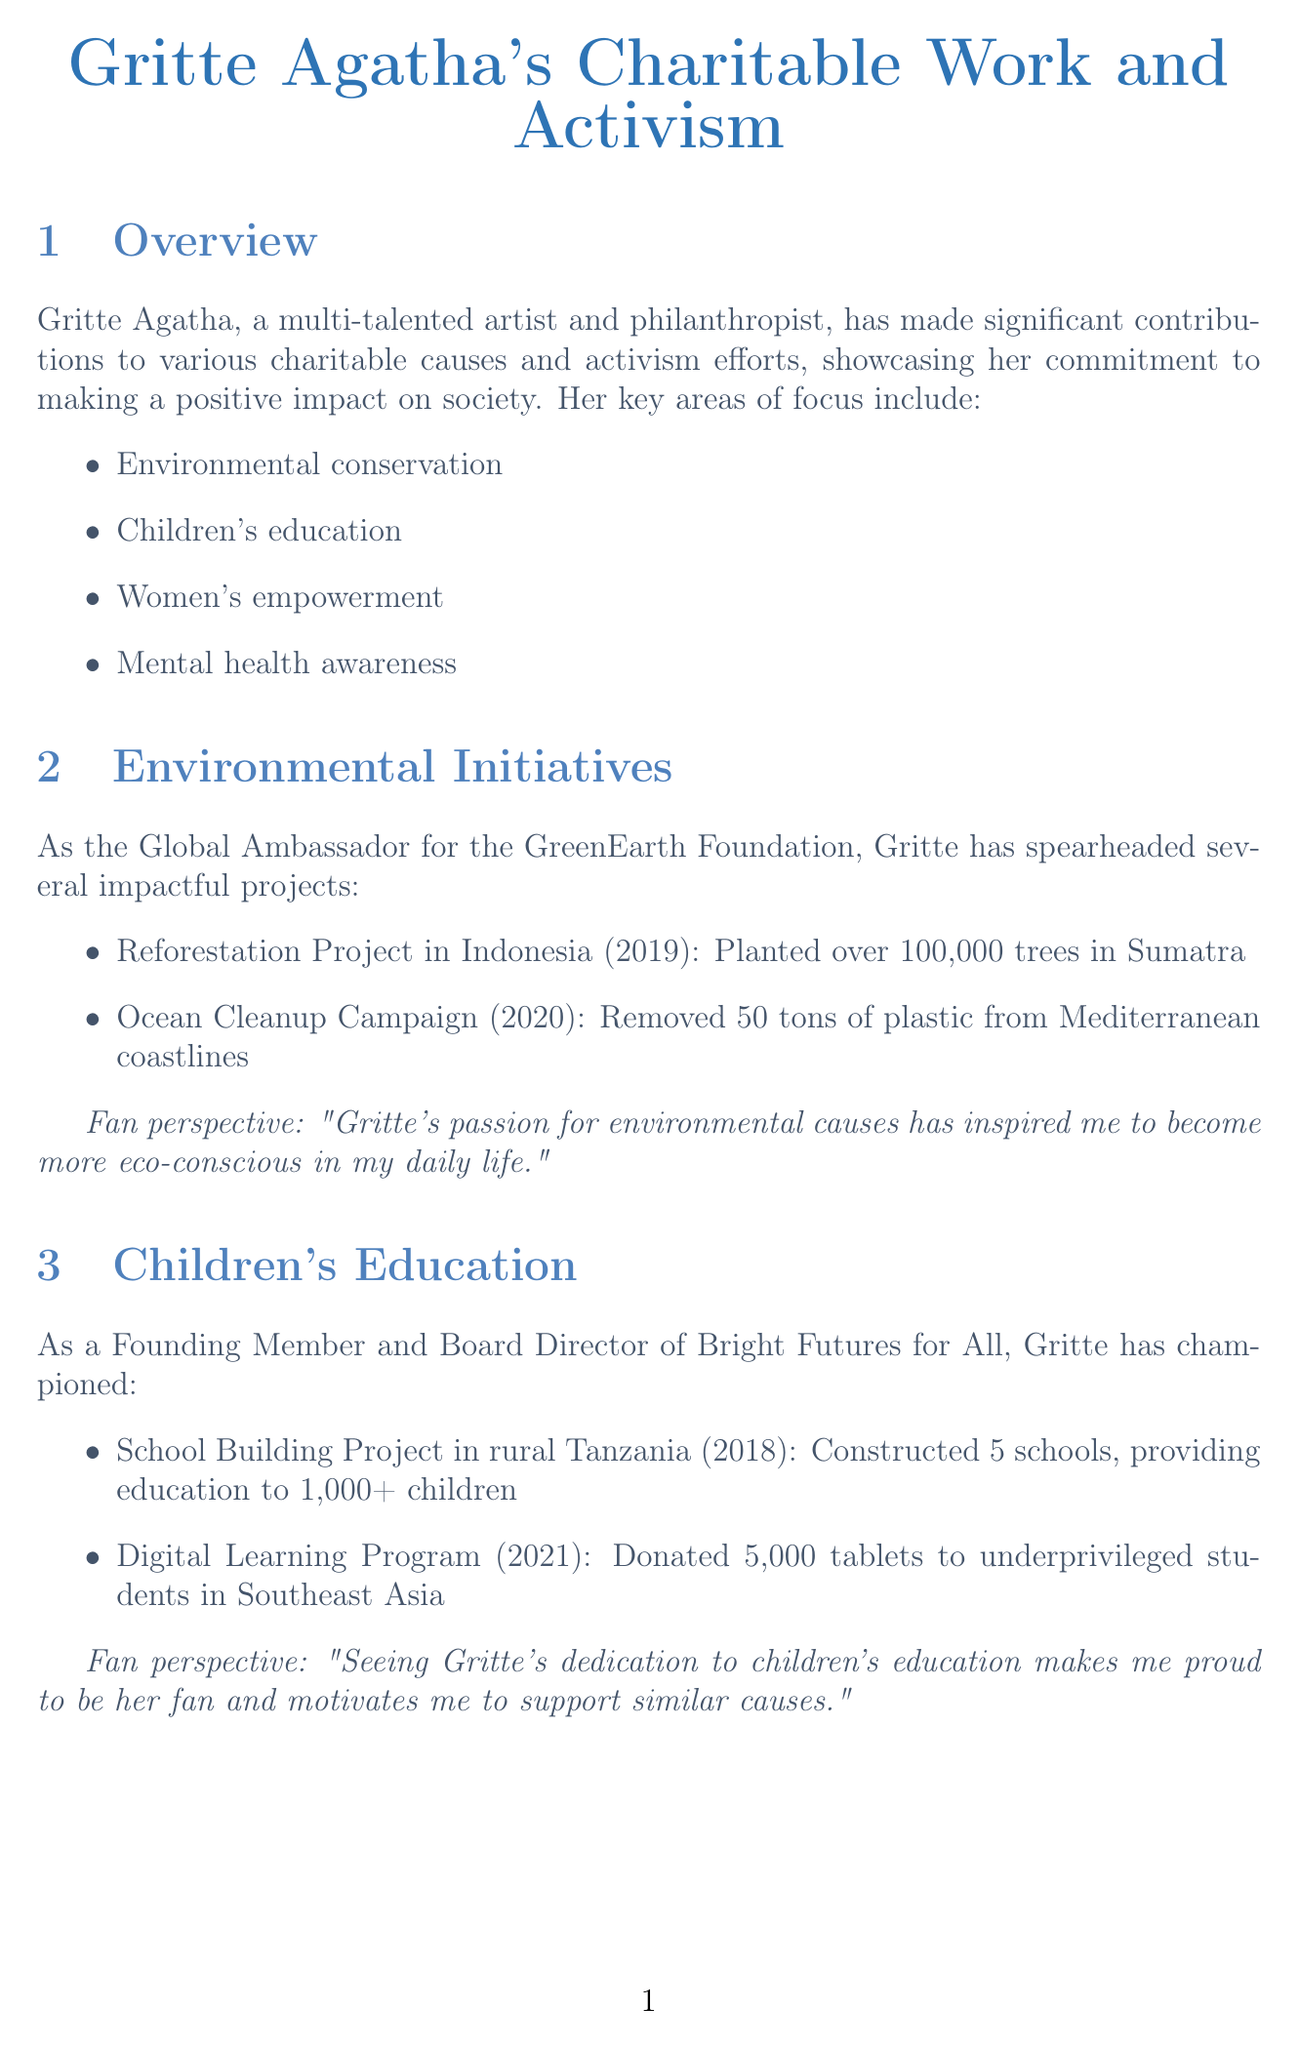What is Gritte Agatha's role in the GreenEarth Foundation? Gritte Agatha serves as the Global Ambassador for the GreenEarth Foundation.
Answer: Global Ambassador How many schools were constructed in the School Building Project in rural Tanzania? The School Building Project resulted in the construction of 5 schools.
Answer: 5 schools What year did Gritte Agatha receive the United Nations Humanitarian Award? The United Nations Humanitarian Award was received in the year 2020.
Answer: 2020 What is the total amount raised during the Voices for Change Concert? The Voices for Change Concert raised a total of $5 million for charitable organizations.
Answer: $5 million How many women were trained in business skills during the Entrepreneurship Workshop Series? The Entrepreneurship Workshop Series trained 500 women in business skills.
Answer: 500 women What is the main focus of Gritte Agatha's upcoming Clean Water Initiative? The Clean Water Initiative focuses on providing clean water access to 100,000 people in Africa.
Answer: Clean water access to 100,000 people in Africa What year did Gritte Agatha’s Ocean Cleanup Campaign take place? The Ocean Cleanup Campaign took place in the year 2020.
Answer: 2020 Which organization is Gritte Agatha a Founding Member of? Gritte Agatha is a Founding Member of Bright Futures for All.
Answer: Bright Futures for All How many veterans participated in the Art Therapy for Veterans workshops? The Art Therapy for Veterans workshops served 1,000 veterans.
Answer: 1,000 veterans 